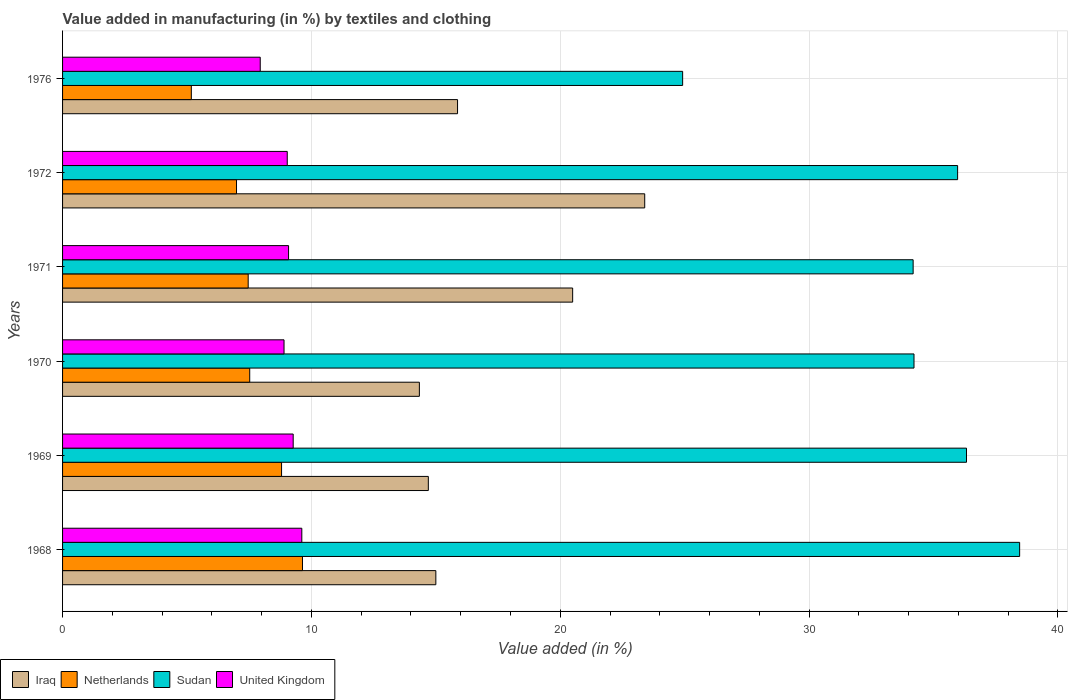How many different coloured bars are there?
Provide a short and direct response. 4. Are the number of bars per tick equal to the number of legend labels?
Make the answer very short. Yes. How many bars are there on the 4th tick from the top?
Your answer should be very brief. 4. What is the label of the 6th group of bars from the top?
Offer a terse response. 1968. In how many cases, is the number of bars for a given year not equal to the number of legend labels?
Provide a short and direct response. 0. What is the percentage of value added in manufacturing by textiles and clothing in Netherlands in 1968?
Make the answer very short. 9.64. Across all years, what is the maximum percentage of value added in manufacturing by textiles and clothing in United Kingdom?
Your answer should be very brief. 9.61. Across all years, what is the minimum percentage of value added in manufacturing by textiles and clothing in Netherlands?
Offer a very short reply. 5.17. In which year was the percentage of value added in manufacturing by textiles and clothing in Sudan maximum?
Your answer should be compact. 1968. In which year was the percentage of value added in manufacturing by textiles and clothing in Netherlands minimum?
Your answer should be very brief. 1976. What is the total percentage of value added in manufacturing by textiles and clothing in Iraq in the graph?
Ensure brevity in your answer.  103.8. What is the difference between the percentage of value added in manufacturing by textiles and clothing in Netherlands in 1969 and that in 1976?
Ensure brevity in your answer.  3.63. What is the difference between the percentage of value added in manufacturing by textiles and clothing in United Kingdom in 1968 and the percentage of value added in manufacturing by textiles and clothing in Sudan in 1972?
Provide a short and direct response. -26.35. What is the average percentage of value added in manufacturing by textiles and clothing in Sudan per year?
Offer a terse response. 34.01. In the year 1968, what is the difference between the percentage of value added in manufacturing by textiles and clothing in Iraq and percentage of value added in manufacturing by textiles and clothing in United Kingdom?
Provide a short and direct response. 5.39. What is the ratio of the percentage of value added in manufacturing by textiles and clothing in Iraq in 1968 to that in 1971?
Give a very brief answer. 0.73. What is the difference between the highest and the second highest percentage of value added in manufacturing by textiles and clothing in United Kingdom?
Make the answer very short. 0.35. What is the difference between the highest and the lowest percentage of value added in manufacturing by textiles and clothing in Netherlands?
Your response must be concise. 4.47. What does the 2nd bar from the top in 1971 represents?
Provide a succinct answer. Sudan. What does the 2nd bar from the bottom in 1972 represents?
Give a very brief answer. Netherlands. Is it the case that in every year, the sum of the percentage of value added in manufacturing by textiles and clothing in United Kingdom and percentage of value added in manufacturing by textiles and clothing in Iraq is greater than the percentage of value added in manufacturing by textiles and clothing in Sudan?
Keep it short and to the point. No. How many bars are there?
Ensure brevity in your answer.  24. Are all the bars in the graph horizontal?
Provide a short and direct response. Yes. How many years are there in the graph?
Provide a succinct answer. 6. Where does the legend appear in the graph?
Offer a terse response. Bottom left. How many legend labels are there?
Your answer should be compact. 4. How are the legend labels stacked?
Offer a terse response. Horizontal. What is the title of the graph?
Make the answer very short. Value added in manufacturing (in %) by textiles and clothing. What is the label or title of the X-axis?
Make the answer very short. Value added (in %). What is the label or title of the Y-axis?
Make the answer very short. Years. What is the Value added (in %) in Iraq in 1968?
Make the answer very short. 15. What is the Value added (in %) of Netherlands in 1968?
Make the answer very short. 9.64. What is the Value added (in %) in Sudan in 1968?
Offer a terse response. 38.46. What is the Value added (in %) in United Kingdom in 1968?
Offer a very short reply. 9.61. What is the Value added (in %) in Iraq in 1969?
Keep it short and to the point. 14.7. What is the Value added (in %) of Netherlands in 1969?
Make the answer very short. 8.8. What is the Value added (in %) of Sudan in 1969?
Keep it short and to the point. 36.32. What is the Value added (in %) of United Kingdom in 1969?
Your answer should be very brief. 9.27. What is the Value added (in %) of Iraq in 1970?
Offer a very short reply. 14.34. What is the Value added (in %) in Netherlands in 1970?
Your answer should be very brief. 7.52. What is the Value added (in %) of Sudan in 1970?
Make the answer very short. 34.21. What is the Value added (in %) in United Kingdom in 1970?
Keep it short and to the point. 8.9. What is the Value added (in %) of Iraq in 1971?
Offer a terse response. 20.5. What is the Value added (in %) of Netherlands in 1971?
Give a very brief answer. 7.46. What is the Value added (in %) of Sudan in 1971?
Provide a succinct answer. 34.18. What is the Value added (in %) in United Kingdom in 1971?
Your response must be concise. 9.08. What is the Value added (in %) of Iraq in 1972?
Ensure brevity in your answer.  23.39. What is the Value added (in %) of Netherlands in 1972?
Make the answer very short. 6.99. What is the Value added (in %) of Sudan in 1972?
Make the answer very short. 35.97. What is the Value added (in %) of United Kingdom in 1972?
Keep it short and to the point. 9.03. What is the Value added (in %) of Iraq in 1976?
Offer a terse response. 15.87. What is the Value added (in %) in Netherlands in 1976?
Keep it short and to the point. 5.17. What is the Value added (in %) of Sudan in 1976?
Offer a very short reply. 24.92. What is the Value added (in %) of United Kingdom in 1976?
Your answer should be compact. 7.94. Across all years, what is the maximum Value added (in %) of Iraq?
Provide a short and direct response. 23.39. Across all years, what is the maximum Value added (in %) of Netherlands?
Make the answer very short. 9.64. Across all years, what is the maximum Value added (in %) of Sudan?
Provide a succinct answer. 38.46. Across all years, what is the maximum Value added (in %) of United Kingdom?
Your response must be concise. 9.61. Across all years, what is the minimum Value added (in %) of Iraq?
Keep it short and to the point. 14.34. Across all years, what is the minimum Value added (in %) in Netherlands?
Your answer should be compact. 5.17. Across all years, what is the minimum Value added (in %) in Sudan?
Offer a terse response. 24.92. Across all years, what is the minimum Value added (in %) of United Kingdom?
Offer a very short reply. 7.94. What is the total Value added (in %) in Iraq in the graph?
Your answer should be compact. 103.8. What is the total Value added (in %) of Netherlands in the graph?
Provide a short and direct response. 45.59. What is the total Value added (in %) of Sudan in the graph?
Your answer should be compact. 204.06. What is the total Value added (in %) of United Kingdom in the graph?
Make the answer very short. 53.84. What is the difference between the Value added (in %) of Iraq in 1968 and that in 1969?
Ensure brevity in your answer.  0.3. What is the difference between the Value added (in %) of Netherlands in 1968 and that in 1969?
Ensure brevity in your answer.  0.84. What is the difference between the Value added (in %) in Sudan in 1968 and that in 1969?
Ensure brevity in your answer.  2.14. What is the difference between the Value added (in %) in United Kingdom in 1968 and that in 1969?
Offer a terse response. 0.35. What is the difference between the Value added (in %) of Iraq in 1968 and that in 1970?
Keep it short and to the point. 0.66. What is the difference between the Value added (in %) of Netherlands in 1968 and that in 1970?
Offer a terse response. 2.12. What is the difference between the Value added (in %) in Sudan in 1968 and that in 1970?
Provide a succinct answer. 4.24. What is the difference between the Value added (in %) in United Kingdom in 1968 and that in 1970?
Give a very brief answer. 0.71. What is the difference between the Value added (in %) in Iraq in 1968 and that in 1971?
Ensure brevity in your answer.  -5.5. What is the difference between the Value added (in %) in Netherlands in 1968 and that in 1971?
Offer a very short reply. 2.18. What is the difference between the Value added (in %) in Sudan in 1968 and that in 1971?
Your answer should be compact. 4.28. What is the difference between the Value added (in %) in United Kingdom in 1968 and that in 1971?
Keep it short and to the point. 0.53. What is the difference between the Value added (in %) of Iraq in 1968 and that in 1972?
Make the answer very short. -8.39. What is the difference between the Value added (in %) of Netherlands in 1968 and that in 1972?
Your answer should be very brief. 2.65. What is the difference between the Value added (in %) in Sudan in 1968 and that in 1972?
Keep it short and to the point. 2.49. What is the difference between the Value added (in %) of United Kingdom in 1968 and that in 1972?
Your response must be concise. 0.59. What is the difference between the Value added (in %) of Iraq in 1968 and that in 1976?
Provide a short and direct response. -0.87. What is the difference between the Value added (in %) of Netherlands in 1968 and that in 1976?
Give a very brief answer. 4.47. What is the difference between the Value added (in %) of Sudan in 1968 and that in 1976?
Ensure brevity in your answer.  13.54. What is the difference between the Value added (in %) of United Kingdom in 1968 and that in 1976?
Keep it short and to the point. 1.67. What is the difference between the Value added (in %) in Iraq in 1969 and that in 1970?
Ensure brevity in your answer.  0.36. What is the difference between the Value added (in %) in Netherlands in 1969 and that in 1970?
Your answer should be compact. 1.28. What is the difference between the Value added (in %) of Sudan in 1969 and that in 1970?
Provide a succinct answer. 2.11. What is the difference between the Value added (in %) in United Kingdom in 1969 and that in 1970?
Make the answer very short. 0.37. What is the difference between the Value added (in %) of Iraq in 1969 and that in 1971?
Give a very brief answer. -5.8. What is the difference between the Value added (in %) of Netherlands in 1969 and that in 1971?
Give a very brief answer. 1.34. What is the difference between the Value added (in %) in Sudan in 1969 and that in 1971?
Make the answer very short. 2.14. What is the difference between the Value added (in %) in United Kingdom in 1969 and that in 1971?
Offer a terse response. 0.19. What is the difference between the Value added (in %) in Iraq in 1969 and that in 1972?
Make the answer very short. -8.7. What is the difference between the Value added (in %) in Netherlands in 1969 and that in 1972?
Keep it short and to the point. 1.81. What is the difference between the Value added (in %) of Sudan in 1969 and that in 1972?
Give a very brief answer. 0.36. What is the difference between the Value added (in %) of United Kingdom in 1969 and that in 1972?
Offer a very short reply. 0.24. What is the difference between the Value added (in %) of Iraq in 1969 and that in 1976?
Your answer should be very brief. -1.17. What is the difference between the Value added (in %) of Netherlands in 1969 and that in 1976?
Ensure brevity in your answer.  3.63. What is the difference between the Value added (in %) in Sudan in 1969 and that in 1976?
Ensure brevity in your answer.  11.41. What is the difference between the Value added (in %) of United Kingdom in 1969 and that in 1976?
Offer a terse response. 1.32. What is the difference between the Value added (in %) of Iraq in 1970 and that in 1971?
Your response must be concise. -6.16. What is the difference between the Value added (in %) in Netherlands in 1970 and that in 1971?
Provide a short and direct response. 0.06. What is the difference between the Value added (in %) of Sudan in 1970 and that in 1971?
Provide a short and direct response. 0.03. What is the difference between the Value added (in %) in United Kingdom in 1970 and that in 1971?
Provide a short and direct response. -0.18. What is the difference between the Value added (in %) of Iraq in 1970 and that in 1972?
Ensure brevity in your answer.  -9.06. What is the difference between the Value added (in %) of Netherlands in 1970 and that in 1972?
Make the answer very short. 0.53. What is the difference between the Value added (in %) of Sudan in 1970 and that in 1972?
Ensure brevity in your answer.  -1.75. What is the difference between the Value added (in %) in United Kingdom in 1970 and that in 1972?
Keep it short and to the point. -0.13. What is the difference between the Value added (in %) in Iraq in 1970 and that in 1976?
Give a very brief answer. -1.53. What is the difference between the Value added (in %) in Netherlands in 1970 and that in 1976?
Give a very brief answer. 2.35. What is the difference between the Value added (in %) of Sudan in 1970 and that in 1976?
Ensure brevity in your answer.  9.3. What is the difference between the Value added (in %) in United Kingdom in 1970 and that in 1976?
Give a very brief answer. 0.96. What is the difference between the Value added (in %) in Iraq in 1971 and that in 1972?
Offer a very short reply. -2.9. What is the difference between the Value added (in %) of Netherlands in 1971 and that in 1972?
Offer a very short reply. 0.47. What is the difference between the Value added (in %) of Sudan in 1971 and that in 1972?
Offer a terse response. -1.79. What is the difference between the Value added (in %) of United Kingdom in 1971 and that in 1972?
Your answer should be compact. 0.05. What is the difference between the Value added (in %) in Iraq in 1971 and that in 1976?
Provide a short and direct response. 4.63. What is the difference between the Value added (in %) in Netherlands in 1971 and that in 1976?
Offer a very short reply. 2.29. What is the difference between the Value added (in %) of Sudan in 1971 and that in 1976?
Your answer should be compact. 9.26. What is the difference between the Value added (in %) of United Kingdom in 1971 and that in 1976?
Your answer should be compact. 1.14. What is the difference between the Value added (in %) of Iraq in 1972 and that in 1976?
Your response must be concise. 7.52. What is the difference between the Value added (in %) in Netherlands in 1972 and that in 1976?
Offer a terse response. 1.82. What is the difference between the Value added (in %) in Sudan in 1972 and that in 1976?
Your answer should be compact. 11.05. What is the difference between the Value added (in %) in United Kingdom in 1972 and that in 1976?
Offer a terse response. 1.09. What is the difference between the Value added (in %) of Iraq in 1968 and the Value added (in %) of Netherlands in 1969?
Your answer should be compact. 6.2. What is the difference between the Value added (in %) in Iraq in 1968 and the Value added (in %) in Sudan in 1969?
Provide a short and direct response. -21.32. What is the difference between the Value added (in %) of Iraq in 1968 and the Value added (in %) of United Kingdom in 1969?
Ensure brevity in your answer.  5.73. What is the difference between the Value added (in %) of Netherlands in 1968 and the Value added (in %) of Sudan in 1969?
Provide a short and direct response. -26.68. What is the difference between the Value added (in %) in Netherlands in 1968 and the Value added (in %) in United Kingdom in 1969?
Give a very brief answer. 0.37. What is the difference between the Value added (in %) in Sudan in 1968 and the Value added (in %) in United Kingdom in 1969?
Your response must be concise. 29.19. What is the difference between the Value added (in %) in Iraq in 1968 and the Value added (in %) in Netherlands in 1970?
Ensure brevity in your answer.  7.48. What is the difference between the Value added (in %) of Iraq in 1968 and the Value added (in %) of Sudan in 1970?
Your response must be concise. -19.21. What is the difference between the Value added (in %) of Iraq in 1968 and the Value added (in %) of United Kingdom in 1970?
Your response must be concise. 6.1. What is the difference between the Value added (in %) of Netherlands in 1968 and the Value added (in %) of Sudan in 1970?
Offer a very short reply. -24.57. What is the difference between the Value added (in %) in Netherlands in 1968 and the Value added (in %) in United Kingdom in 1970?
Your answer should be very brief. 0.74. What is the difference between the Value added (in %) in Sudan in 1968 and the Value added (in %) in United Kingdom in 1970?
Your response must be concise. 29.56. What is the difference between the Value added (in %) in Iraq in 1968 and the Value added (in %) in Netherlands in 1971?
Offer a very short reply. 7.54. What is the difference between the Value added (in %) in Iraq in 1968 and the Value added (in %) in Sudan in 1971?
Offer a very short reply. -19.18. What is the difference between the Value added (in %) in Iraq in 1968 and the Value added (in %) in United Kingdom in 1971?
Offer a terse response. 5.92. What is the difference between the Value added (in %) in Netherlands in 1968 and the Value added (in %) in Sudan in 1971?
Keep it short and to the point. -24.54. What is the difference between the Value added (in %) of Netherlands in 1968 and the Value added (in %) of United Kingdom in 1971?
Your answer should be very brief. 0.56. What is the difference between the Value added (in %) in Sudan in 1968 and the Value added (in %) in United Kingdom in 1971?
Provide a short and direct response. 29.38. What is the difference between the Value added (in %) of Iraq in 1968 and the Value added (in %) of Netherlands in 1972?
Keep it short and to the point. 8.01. What is the difference between the Value added (in %) of Iraq in 1968 and the Value added (in %) of Sudan in 1972?
Provide a short and direct response. -20.97. What is the difference between the Value added (in %) in Iraq in 1968 and the Value added (in %) in United Kingdom in 1972?
Offer a terse response. 5.97. What is the difference between the Value added (in %) in Netherlands in 1968 and the Value added (in %) in Sudan in 1972?
Make the answer very short. -26.33. What is the difference between the Value added (in %) of Netherlands in 1968 and the Value added (in %) of United Kingdom in 1972?
Your answer should be compact. 0.61. What is the difference between the Value added (in %) in Sudan in 1968 and the Value added (in %) in United Kingdom in 1972?
Offer a terse response. 29.43. What is the difference between the Value added (in %) in Iraq in 1968 and the Value added (in %) in Netherlands in 1976?
Offer a very short reply. 9.83. What is the difference between the Value added (in %) in Iraq in 1968 and the Value added (in %) in Sudan in 1976?
Ensure brevity in your answer.  -9.92. What is the difference between the Value added (in %) in Iraq in 1968 and the Value added (in %) in United Kingdom in 1976?
Ensure brevity in your answer.  7.06. What is the difference between the Value added (in %) of Netherlands in 1968 and the Value added (in %) of Sudan in 1976?
Your answer should be compact. -15.28. What is the difference between the Value added (in %) in Netherlands in 1968 and the Value added (in %) in United Kingdom in 1976?
Your answer should be very brief. 1.7. What is the difference between the Value added (in %) in Sudan in 1968 and the Value added (in %) in United Kingdom in 1976?
Your response must be concise. 30.52. What is the difference between the Value added (in %) in Iraq in 1969 and the Value added (in %) in Netherlands in 1970?
Your answer should be very brief. 7.18. What is the difference between the Value added (in %) in Iraq in 1969 and the Value added (in %) in Sudan in 1970?
Your answer should be very brief. -19.52. What is the difference between the Value added (in %) in Iraq in 1969 and the Value added (in %) in United Kingdom in 1970?
Your answer should be compact. 5.8. What is the difference between the Value added (in %) in Netherlands in 1969 and the Value added (in %) in Sudan in 1970?
Make the answer very short. -25.41. What is the difference between the Value added (in %) in Netherlands in 1969 and the Value added (in %) in United Kingdom in 1970?
Provide a succinct answer. -0.1. What is the difference between the Value added (in %) of Sudan in 1969 and the Value added (in %) of United Kingdom in 1970?
Give a very brief answer. 27.42. What is the difference between the Value added (in %) of Iraq in 1969 and the Value added (in %) of Netherlands in 1971?
Keep it short and to the point. 7.24. What is the difference between the Value added (in %) in Iraq in 1969 and the Value added (in %) in Sudan in 1971?
Your response must be concise. -19.48. What is the difference between the Value added (in %) of Iraq in 1969 and the Value added (in %) of United Kingdom in 1971?
Provide a short and direct response. 5.62. What is the difference between the Value added (in %) in Netherlands in 1969 and the Value added (in %) in Sudan in 1971?
Offer a very short reply. -25.38. What is the difference between the Value added (in %) of Netherlands in 1969 and the Value added (in %) of United Kingdom in 1971?
Your response must be concise. -0.28. What is the difference between the Value added (in %) in Sudan in 1969 and the Value added (in %) in United Kingdom in 1971?
Keep it short and to the point. 27.24. What is the difference between the Value added (in %) in Iraq in 1969 and the Value added (in %) in Netherlands in 1972?
Offer a terse response. 7.71. What is the difference between the Value added (in %) in Iraq in 1969 and the Value added (in %) in Sudan in 1972?
Provide a short and direct response. -21.27. What is the difference between the Value added (in %) in Iraq in 1969 and the Value added (in %) in United Kingdom in 1972?
Your response must be concise. 5.67. What is the difference between the Value added (in %) in Netherlands in 1969 and the Value added (in %) in Sudan in 1972?
Offer a terse response. -27.17. What is the difference between the Value added (in %) in Netherlands in 1969 and the Value added (in %) in United Kingdom in 1972?
Your response must be concise. -0.23. What is the difference between the Value added (in %) of Sudan in 1969 and the Value added (in %) of United Kingdom in 1972?
Ensure brevity in your answer.  27.3. What is the difference between the Value added (in %) in Iraq in 1969 and the Value added (in %) in Netherlands in 1976?
Your response must be concise. 9.52. What is the difference between the Value added (in %) of Iraq in 1969 and the Value added (in %) of Sudan in 1976?
Provide a short and direct response. -10.22. What is the difference between the Value added (in %) of Iraq in 1969 and the Value added (in %) of United Kingdom in 1976?
Provide a short and direct response. 6.75. What is the difference between the Value added (in %) in Netherlands in 1969 and the Value added (in %) in Sudan in 1976?
Provide a short and direct response. -16.12. What is the difference between the Value added (in %) of Netherlands in 1969 and the Value added (in %) of United Kingdom in 1976?
Give a very brief answer. 0.86. What is the difference between the Value added (in %) in Sudan in 1969 and the Value added (in %) in United Kingdom in 1976?
Make the answer very short. 28.38. What is the difference between the Value added (in %) of Iraq in 1970 and the Value added (in %) of Netherlands in 1971?
Ensure brevity in your answer.  6.88. What is the difference between the Value added (in %) in Iraq in 1970 and the Value added (in %) in Sudan in 1971?
Your answer should be compact. -19.84. What is the difference between the Value added (in %) in Iraq in 1970 and the Value added (in %) in United Kingdom in 1971?
Provide a succinct answer. 5.26. What is the difference between the Value added (in %) of Netherlands in 1970 and the Value added (in %) of Sudan in 1971?
Make the answer very short. -26.66. What is the difference between the Value added (in %) of Netherlands in 1970 and the Value added (in %) of United Kingdom in 1971?
Ensure brevity in your answer.  -1.56. What is the difference between the Value added (in %) of Sudan in 1970 and the Value added (in %) of United Kingdom in 1971?
Ensure brevity in your answer.  25.13. What is the difference between the Value added (in %) of Iraq in 1970 and the Value added (in %) of Netherlands in 1972?
Offer a very short reply. 7.35. What is the difference between the Value added (in %) in Iraq in 1970 and the Value added (in %) in Sudan in 1972?
Offer a terse response. -21.63. What is the difference between the Value added (in %) in Iraq in 1970 and the Value added (in %) in United Kingdom in 1972?
Offer a very short reply. 5.31. What is the difference between the Value added (in %) of Netherlands in 1970 and the Value added (in %) of Sudan in 1972?
Keep it short and to the point. -28.45. What is the difference between the Value added (in %) in Netherlands in 1970 and the Value added (in %) in United Kingdom in 1972?
Keep it short and to the point. -1.51. What is the difference between the Value added (in %) in Sudan in 1970 and the Value added (in %) in United Kingdom in 1972?
Keep it short and to the point. 25.19. What is the difference between the Value added (in %) in Iraq in 1970 and the Value added (in %) in Netherlands in 1976?
Provide a short and direct response. 9.16. What is the difference between the Value added (in %) of Iraq in 1970 and the Value added (in %) of Sudan in 1976?
Ensure brevity in your answer.  -10.58. What is the difference between the Value added (in %) in Iraq in 1970 and the Value added (in %) in United Kingdom in 1976?
Give a very brief answer. 6.39. What is the difference between the Value added (in %) in Netherlands in 1970 and the Value added (in %) in Sudan in 1976?
Make the answer very short. -17.4. What is the difference between the Value added (in %) in Netherlands in 1970 and the Value added (in %) in United Kingdom in 1976?
Give a very brief answer. -0.42. What is the difference between the Value added (in %) of Sudan in 1970 and the Value added (in %) of United Kingdom in 1976?
Your answer should be very brief. 26.27. What is the difference between the Value added (in %) of Iraq in 1971 and the Value added (in %) of Netherlands in 1972?
Your answer should be very brief. 13.51. What is the difference between the Value added (in %) of Iraq in 1971 and the Value added (in %) of Sudan in 1972?
Your answer should be compact. -15.47. What is the difference between the Value added (in %) of Iraq in 1971 and the Value added (in %) of United Kingdom in 1972?
Your answer should be compact. 11.47. What is the difference between the Value added (in %) of Netherlands in 1971 and the Value added (in %) of Sudan in 1972?
Your answer should be compact. -28.51. What is the difference between the Value added (in %) of Netherlands in 1971 and the Value added (in %) of United Kingdom in 1972?
Your answer should be compact. -1.57. What is the difference between the Value added (in %) of Sudan in 1971 and the Value added (in %) of United Kingdom in 1972?
Your answer should be compact. 25.15. What is the difference between the Value added (in %) of Iraq in 1971 and the Value added (in %) of Netherlands in 1976?
Provide a succinct answer. 15.32. What is the difference between the Value added (in %) of Iraq in 1971 and the Value added (in %) of Sudan in 1976?
Your answer should be compact. -4.42. What is the difference between the Value added (in %) in Iraq in 1971 and the Value added (in %) in United Kingdom in 1976?
Make the answer very short. 12.55. What is the difference between the Value added (in %) in Netherlands in 1971 and the Value added (in %) in Sudan in 1976?
Your answer should be compact. -17.46. What is the difference between the Value added (in %) in Netherlands in 1971 and the Value added (in %) in United Kingdom in 1976?
Your response must be concise. -0.48. What is the difference between the Value added (in %) in Sudan in 1971 and the Value added (in %) in United Kingdom in 1976?
Make the answer very short. 26.24. What is the difference between the Value added (in %) in Iraq in 1972 and the Value added (in %) in Netherlands in 1976?
Make the answer very short. 18.22. What is the difference between the Value added (in %) of Iraq in 1972 and the Value added (in %) of Sudan in 1976?
Ensure brevity in your answer.  -1.52. What is the difference between the Value added (in %) of Iraq in 1972 and the Value added (in %) of United Kingdom in 1976?
Keep it short and to the point. 15.45. What is the difference between the Value added (in %) of Netherlands in 1972 and the Value added (in %) of Sudan in 1976?
Offer a terse response. -17.93. What is the difference between the Value added (in %) in Netherlands in 1972 and the Value added (in %) in United Kingdom in 1976?
Your answer should be very brief. -0.95. What is the difference between the Value added (in %) in Sudan in 1972 and the Value added (in %) in United Kingdom in 1976?
Provide a succinct answer. 28.02. What is the average Value added (in %) of Iraq per year?
Your answer should be very brief. 17.3. What is the average Value added (in %) in Netherlands per year?
Make the answer very short. 7.6. What is the average Value added (in %) of Sudan per year?
Your answer should be compact. 34.01. What is the average Value added (in %) in United Kingdom per year?
Keep it short and to the point. 8.97. In the year 1968, what is the difference between the Value added (in %) of Iraq and Value added (in %) of Netherlands?
Your response must be concise. 5.36. In the year 1968, what is the difference between the Value added (in %) of Iraq and Value added (in %) of Sudan?
Make the answer very short. -23.46. In the year 1968, what is the difference between the Value added (in %) in Iraq and Value added (in %) in United Kingdom?
Make the answer very short. 5.39. In the year 1968, what is the difference between the Value added (in %) of Netherlands and Value added (in %) of Sudan?
Your answer should be very brief. -28.82. In the year 1968, what is the difference between the Value added (in %) in Netherlands and Value added (in %) in United Kingdom?
Your answer should be compact. 0.03. In the year 1968, what is the difference between the Value added (in %) of Sudan and Value added (in %) of United Kingdom?
Give a very brief answer. 28.85. In the year 1969, what is the difference between the Value added (in %) in Iraq and Value added (in %) in Netherlands?
Ensure brevity in your answer.  5.9. In the year 1969, what is the difference between the Value added (in %) of Iraq and Value added (in %) of Sudan?
Your answer should be compact. -21.63. In the year 1969, what is the difference between the Value added (in %) in Iraq and Value added (in %) in United Kingdom?
Provide a succinct answer. 5.43. In the year 1969, what is the difference between the Value added (in %) of Netherlands and Value added (in %) of Sudan?
Ensure brevity in your answer.  -27.52. In the year 1969, what is the difference between the Value added (in %) of Netherlands and Value added (in %) of United Kingdom?
Your response must be concise. -0.47. In the year 1969, what is the difference between the Value added (in %) of Sudan and Value added (in %) of United Kingdom?
Ensure brevity in your answer.  27.06. In the year 1970, what is the difference between the Value added (in %) of Iraq and Value added (in %) of Netherlands?
Provide a short and direct response. 6.82. In the year 1970, what is the difference between the Value added (in %) of Iraq and Value added (in %) of Sudan?
Make the answer very short. -19.88. In the year 1970, what is the difference between the Value added (in %) of Iraq and Value added (in %) of United Kingdom?
Keep it short and to the point. 5.44. In the year 1970, what is the difference between the Value added (in %) in Netherlands and Value added (in %) in Sudan?
Your answer should be very brief. -26.69. In the year 1970, what is the difference between the Value added (in %) in Netherlands and Value added (in %) in United Kingdom?
Make the answer very short. -1.38. In the year 1970, what is the difference between the Value added (in %) of Sudan and Value added (in %) of United Kingdom?
Your answer should be compact. 25.32. In the year 1971, what is the difference between the Value added (in %) in Iraq and Value added (in %) in Netherlands?
Your answer should be very brief. 13.04. In the year 1971, what is the difference between the Value added (in %) of Iraq and Value added (in %) of Sudan?
Give a very brief answer. -13.68. In the year 1971, what is the difference between the Value added (in %) in Iraq and Value added (in %) in United Kingdom?
Provide a short and direct response. 11.42. In the year 1971, what is the difference between the Value added (in %) in Netherlands and Value added (in %) in Sudan?
Ensure brevity in your answer.  -26.72. In the year 1971, what is the difference between the Value added (in %) of Netherlands and Value added (in %) of United Kingdom?
Provide a succinct answer. -1.62. In the year 1971, what is the difference between the Value added (in %) in Sudan and Value added (in %) in United Kingdom?
Make the answer very short. 25.1. In the year 1972, what is the difference between the Value added (in %) in Iraq and Value added (in %) in Netherlands?
Provide a short and direct response. 16.4. In the year 1972, what is the difference between the Value added (in %) of Iraq and Value added (in %) of Sudan?
Give a very brief answer. -12.57. In the year 1972, what is the difference between the Value added (in %) of Iraq and Value added (in %) of United Kingdom?
Offer a terse response. 14.36. In the year 1972, what is the difference between the Value added (in %) in Netherlands and Value added (in %) in Sudan?
Provide a short and direct response. -28.98. In the year 1972, what is the difference between the Value added (in %) in Netherlands and Value added (in %) in United Kingdom?
Make the answer very short. -2.04. In the year 1972, what is the difference between the Value added (in %) in Sudan and Value added (in %) in United Kingdom?
Provide a succinct answer. 26.94. In the year 1976, what is the difference between the Value added (in %) in Iraq and Value added (in %) in Netherlands?
Offer a very short reply. 10.7. In the year 1976, what is the difference between the Value added (in %) of Iraq and Value added (in %) of Sudan?
Offer a terse response. -9.05. In the year 1976, what is the difference between the Value added (in %) of Iraq and Value added (in %) of United Kingdom?
Your response must be concise. 7.93. In the year 1976, what is the difference between the Value added (in %) of Netherlands and Value added (in %) of Sudan?
Offer a very short reply. -19.74. In the year 1976, what is the difference between the Value added (in %) of Netherlands and Value added (in %) of United Kingdom?
Give a very brief answer. -2.77. In the year 1976, what is the difference between the Value added (in %) in Sudan and Value added (in %) in United Kingdom?
Your answer should be compact. 16.97. What is the ratio of the Value added (in %) of Iraq in 1968 to that in 1969?
Offer a terse response. 1.02. What is the ratio of the Value added (in %) of Netherlands in 1968 to that in 1969?
Provide a succinct answer. 1.1. What is the ratio of the Value added (in %) in Sudan in 1968 to that in 1969?
Offer a terse response. 1.06. What is the ratio of the Value added (in %) of United Kingdom in 1968 to that in 1969?
Keep it short and to the point. 1.04. What is the ratio of the Value added (in %) in Iraq in 1968 to that in 1970?
Offer a very short reply. 1.05. What is the ratio of the Value added (in %) in Netherlands in 1968 to that in 1970?
Keep it short and to the point. 1.28. What is the ratio of the Value added (in %) in Sudan in 1968 to that in 1970?
Offer a very short reply. 1.12. What is the ratio of the Value added (in %) in United Kingdom in 1968 to that in 1970?
Your response must be concise. 1.08. What is the ratio of the Value added (in %) of Iraq in 1968 to that in 1971?
Keep it short and to the point. 0.73. What is the ratio of the Value added (in %) of Netherlands in 1968 to that in 1971?
Give a very brief answer. 1.29. What is the ratio of the Value added (in %) in Sudan in 1968 to that in 1971?
Keep it short and to the point. 1.13. What is the ratio of the Value added (in %) in United Kingdom in 1968 to that in 1971?
Ensure brevity in your answer.  1.06. What is the ratio of the Value added (in %) of Iraq in 1968 to that in 1972?
Keep it short and to the point. 0.64. What is the ratio of the Value added (in %) in Netherlands in 1968 to that in 1972?
Provide a succinct answer. 1.38. What is the ratio of the Value added (in %) of Sudan in 1968 to that in 1972?
Ensure brevity in your answer.  1.07. What is the ratio of the Value added (in %) of United Kingdom in 1968 to that in 1972?
Give a very brief answer. 1.06. What is the ratio of the Value added (in %) in Iraq in 1968 to that in 1976?
Offer a terse response. 0.95. What is the ratio of the Value added (in %) in Netherlands in 1968 to that in 1976?
Offer a terse response. 1.86. What is the ratio of the Value added (in %) of Sudan in 1968 to that in 1976?
Keep it short and to the point. 1.54. What is the ratio of the Value added (in %) of United Kingdom in 1968 to that in 1976?
Offer a terse response. 1.21. What is the ratio of the Value added (in %) in Iraq in 1969 to that in 1970?
Keep it short and to the point. 1.03. What is the ratio of the Value added (in %) of Netherlands in 1969 to that in 1970?
Your response must be concise. 1.17. What is the ratio of the Value added (in %) of Sudan in 1969 to that in 1970?
Keep it short and to the point. 1.06. What is the ratio of the Value added (in %) of United Kingdom in 1969 to that in 1970?
Give a very brief answer. 1.04. What is the ratio of the Value added (in %) in Iraq in 1969 to that in 1971?
Your response must be concise. 0.72. What is the ratio of the Value added (in %) in Netherlands in 1969 to that in 1971?
Provide a succinct answer. 1.18. What is the ratio of the Value added (in %) of Sudan in 1969 to that in 1971?
Your answer should be very brief. 1.06. What is the ratio of the Value added (in %) of United Kingdom in 1969 to that in 1971?
Make the answer very short. 1.02. What is the ratio of the Value added (in %) of Iraq in 1969 to that in 1972?
Your response must be concise. 0.63. What is the ratio of the Value added (in %) in Netherlands in 1969 to that in 1972?
Provide a short and direct response. 1.26. What is the ratio of the Value added (in %) in Sudan in 1969 to that in 1972?
Make the answer very short. 1.01. What is the ratio of the Value added (in %) in United Kingdom in 1969 to that in 1972?
Your answer should be very brief. 1.03. What is the ratio of the Value added (in %) of Iraq in 1969 to that in 1976?
Keep it short and to the point. 0.93. What is the ratio of the Value added (in %) in Netherlands in 1969 to that in 1976?
Make the answer very short. 1.7. What is the ratio of the Value added (in %) in Sudan in 1969 to that in 1976?
Keep it short and to the point. 1.46. What is the ratio of the Value added (in %) in United Kingdom in 1969 to that in 1976?
Provide a succinct answer. 1.17. What is the ratio of the Value added (in %) in Iraq in 1970 to that in 1971?
Provide a short and direct response. 0.7. What is the ratio of the Value added (in %) of Netherlands in 1970 to that in 1971?
Offer a terse response. 1.01. What is the ratio of the Value added (in %) in Iraq in 1970 to that in 1972?
Ensure brevity in your answer.  0.61. What is the ratio of the Value added (in %) in Netherlands in 1970 to that in 1972?
Make the answer very short. 1.08. What is the ratio of the Value added (in %) in Sudan in 1970 to that in 1972?
Make the answer very short. 0.95. What is the ratio of the Value added (in %) of United Kingdom in 1970 to that in 1972?
Provide a short and direct response. 0.99. What is the ratio of the Value added (in %) of Iraq in 1970 to that in 1976?
Your answer should be very brief. 0.9. What is the ratio of the Value added (in %) of Netherlands in 1970 to that in 1976?
Keep it short and to the point. 1.45. What is the ratio of the Value added (in %) of Sudan in 1970 to that in 1976?
Your response must be concise. 1.37. What is the ratio of the Value added (in %) in United Kingdom in 1970 to that in 1976?
Offer a very short reply. 1.12. What is the ratio of the Value added (in %) of Iraq in 1971 to that in 1972?
Give a very brief answer. 0.88. What is the ratio of the Value added (in %) in Netherlands in 1971 to that in 1972?
Give a very brief answer. 1.07. What is the ratio of the Value added (in %) in Sudan in 1971 to that in 1972?
Your answer should be compact. 0.95. What is the ratio of the Value added (in %) in United Kingdom in 1971 to that in 1972?
Provide a short and direct response. 1.01. What is the ratio of the Value added (in %) in Iraq in 1971 to that in 1976?
Your response must be concise. 1.29. What is the ratio of the Value added (in %) of Netherlands in 1971 to that in 1976?
Ensure brevity in your answer.  1.44. What is the ratio of the Value added (in %) in Sudan in 1971 to that in 1976?
Provide a succinct answer. 1.37. What is the ratio of the Value added (in %) in United Kingdom in 1971 to that in 1976?
Give a very brief answer. 1.14. What is the ratio of the Value added (in %) in Iraq in 1972 to that in 1976?
Provide a short and direct response. 1.47. What is the ratio of the Value added (in %) of Netherlands in 1972 to that in 1976?
Offer a very short reply. 1.35. What is the ratio of the Value added (in %) of Sudan in 1972 to that in 1976?
Your response must be concise. 1.44. What is the ratio of the Value added (in %) of United Kingdom in 1972 to that in 1976?
Offer a terse response. 1.14. What is the difference between the highest and the second highest Value added (in %) in Iraq?
Offer a terse response. 2.9. What is the difference between the highest and the second highest Value added (in %) in Netherlands?
Keep it short and to the point. 0.84. What is the difference between the highest and the second highest Value added (in %) of Sudan?
Offer a very short reply. 2.14. What is the difference between the highest and the second highest Value added (in %) in United Kingdom?
Make the answer very short. 0.35. What is the difference between the highest and the lowest Value added (in %) of Iraq?
Your answer should be very brief. 9.06. What is the difference between the highest and the lowest Value added (in %) of Netherlands?
Ensure brevity in your answer.  4.47. What is the difference between the highest and the lowest Value added (in %) in Sudan?
Your response must be concise. 13.54. What is the difference between the highest and the lowest Value added (in %) in United Kingdom?
Provide a short and direct response. 1.67. 